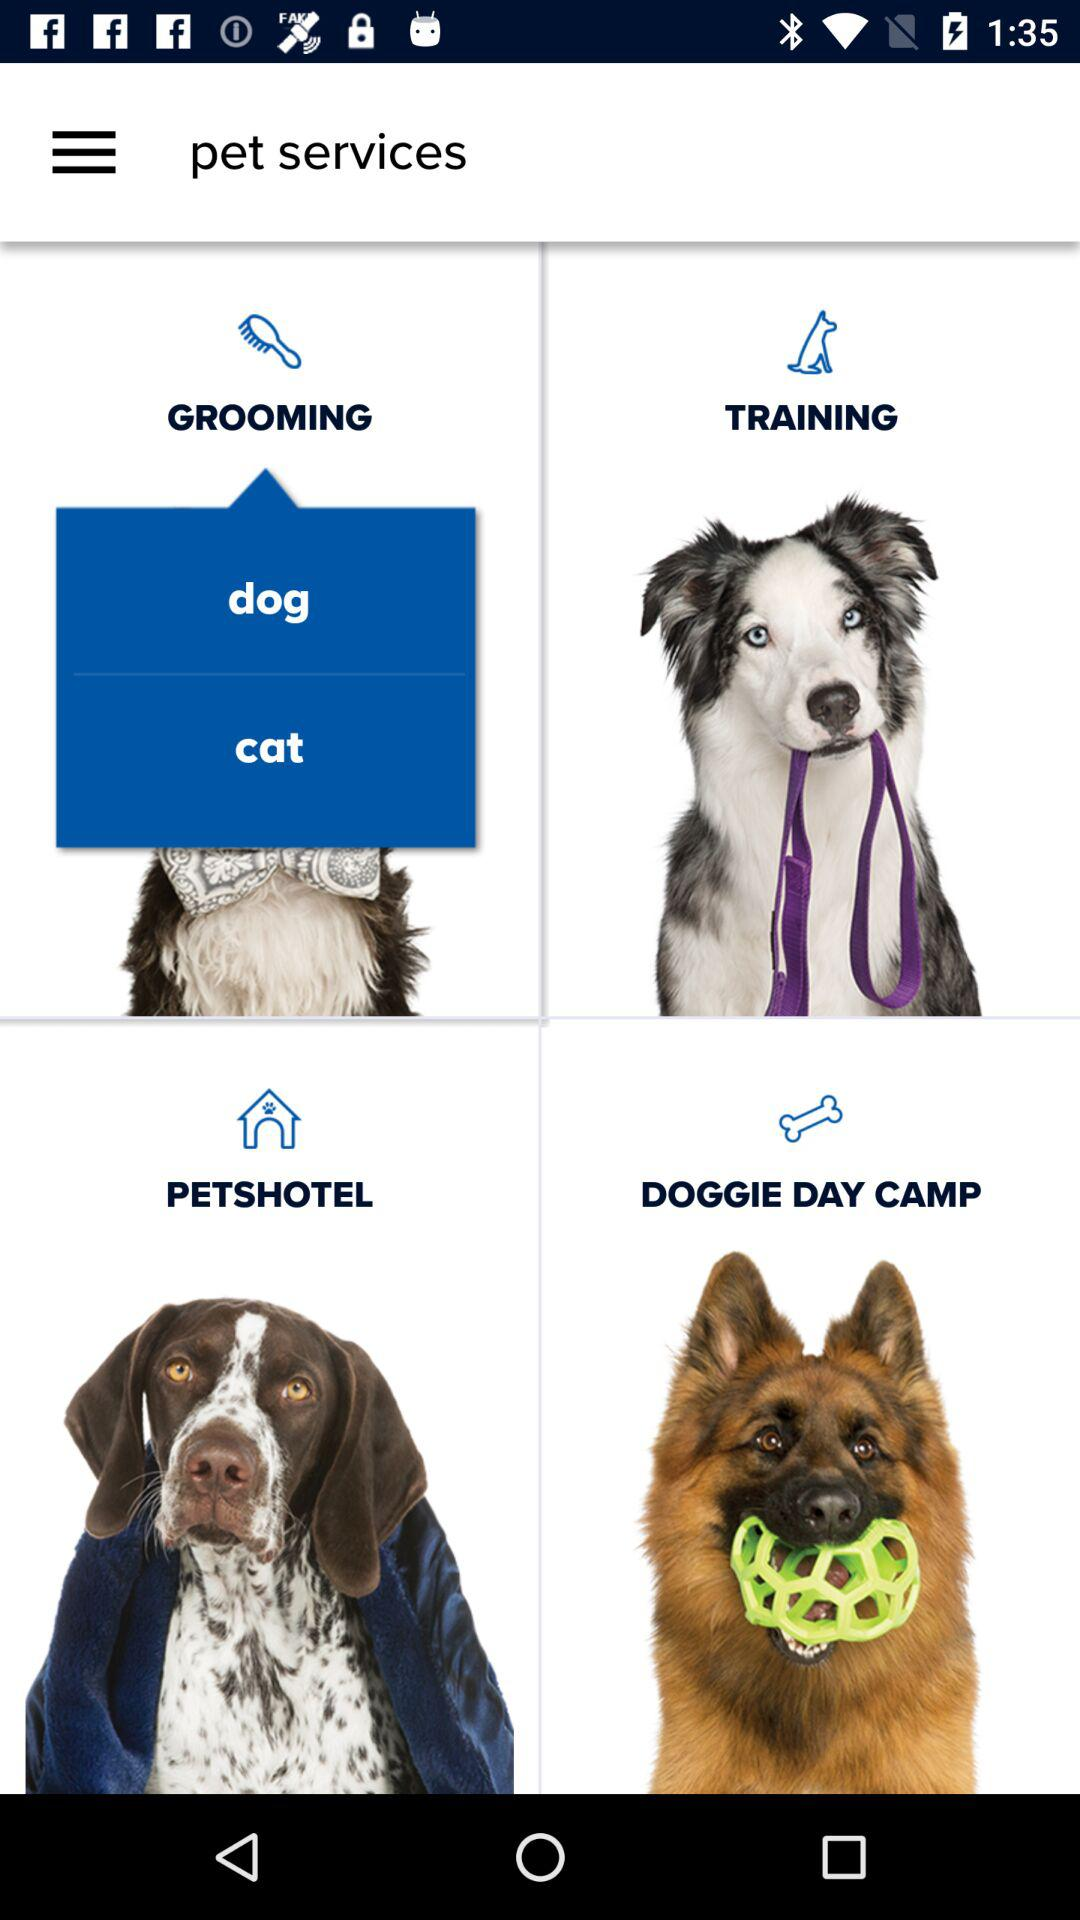What is the name of application?
When the provided information is insufficient, respond with <no answer>. <no answer> 